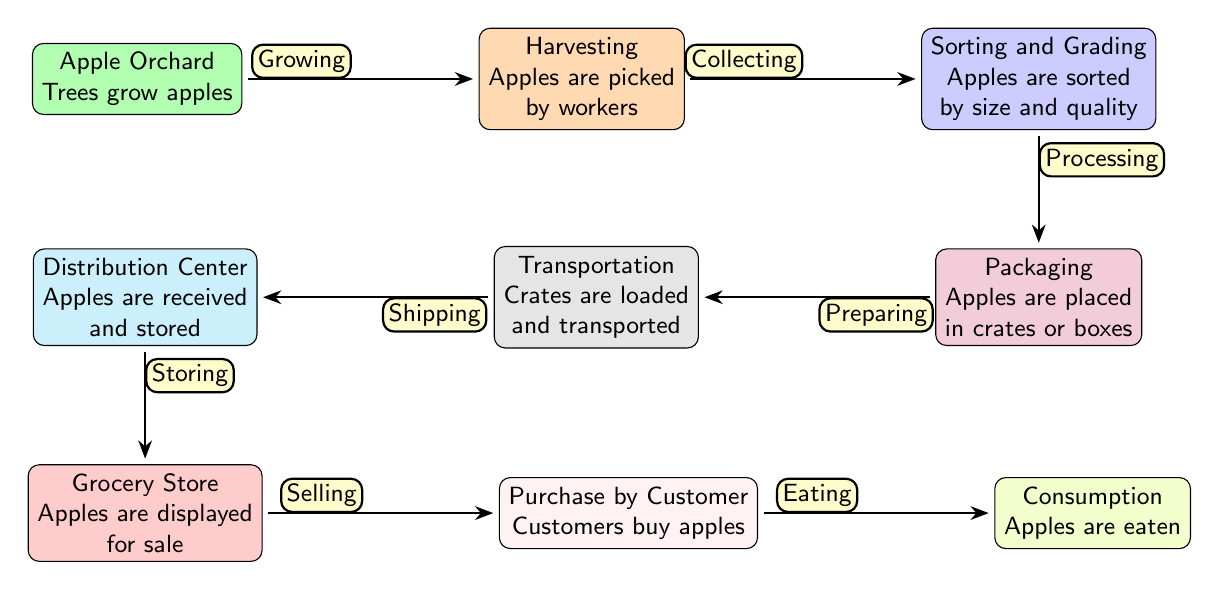What is the first step in the lifecycle of the apple? The first step is the Apple Orchard, where trees grow apples.
Answer: Apple Orchard How many nodes are in the diagram? The diagram contains 9 nodes that represent different stages in the lifecycle of an apple.
Answer: 9 What happens after sorting and grading? After sorting and grading, the apples are packaged.
Answer: Packaging What is the final action taken on the apples? The final action is Consumption, where apples are eaten.
Answer: Consumption Which node is directly above the Grocery Store? The node directly above the Grocery Store is the Distribution Center.
Answer: Distribution Center What is the relationship between Harvesting and Sorting and Grading? The relationship is labeled as "Collecting," which indicates the process of transitioning from harvesting to sorting and grading.
Answer: Collecting Which step involves transporting crates? The step that involves transporting crates is Transportation.
Answer: Transportation What stage follows Purchase by Customer? The stage that follows Purchase by Customer is Consumption.
Answer: Consumption What is the color of the Sorting and Grading node? The color of the Sorting and Grading node is blue.
Answer: Blue 